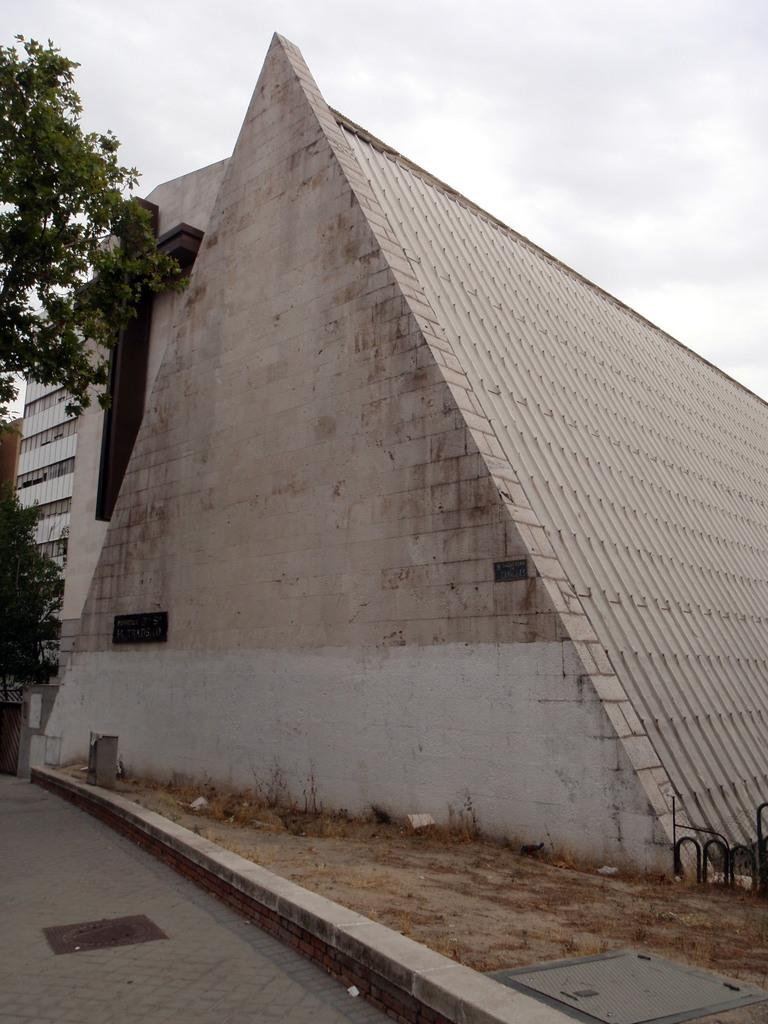What is the main structure in the center of the image? There is a pyramid structure in the center of the image. What other objects or features can be seen in the image? There is a tree and a pavement at the bottom of the image. The sky is also visible at the top of the image. How many porters are carrying the pyramid in the image? There are no porters present in the image, and the pyramid is not being carried. What type of polish is applied to the tree in the image? There is no mention of any polish being applied to the tree in the image. 